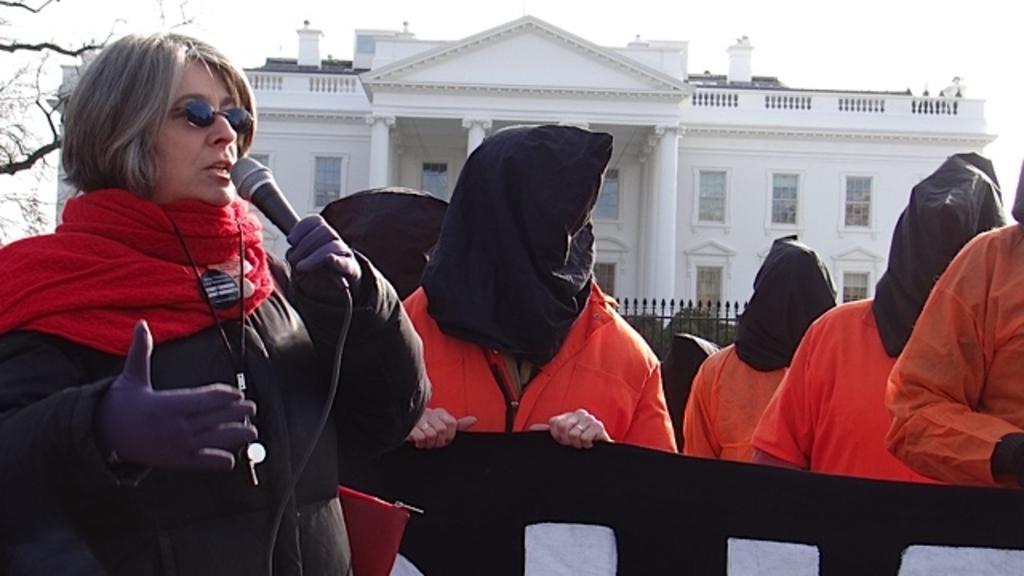In one or two sentences, can you explain what this image depicts? This image consists of many people. On the left, there is a woman wearing a black jacket and talking in a mic. On the right, there are few people wearing orange jackets and their faces are covered with the blinds. In the background, there is a building in white color. On the left, we can see a tree. At the top, there is sky. 